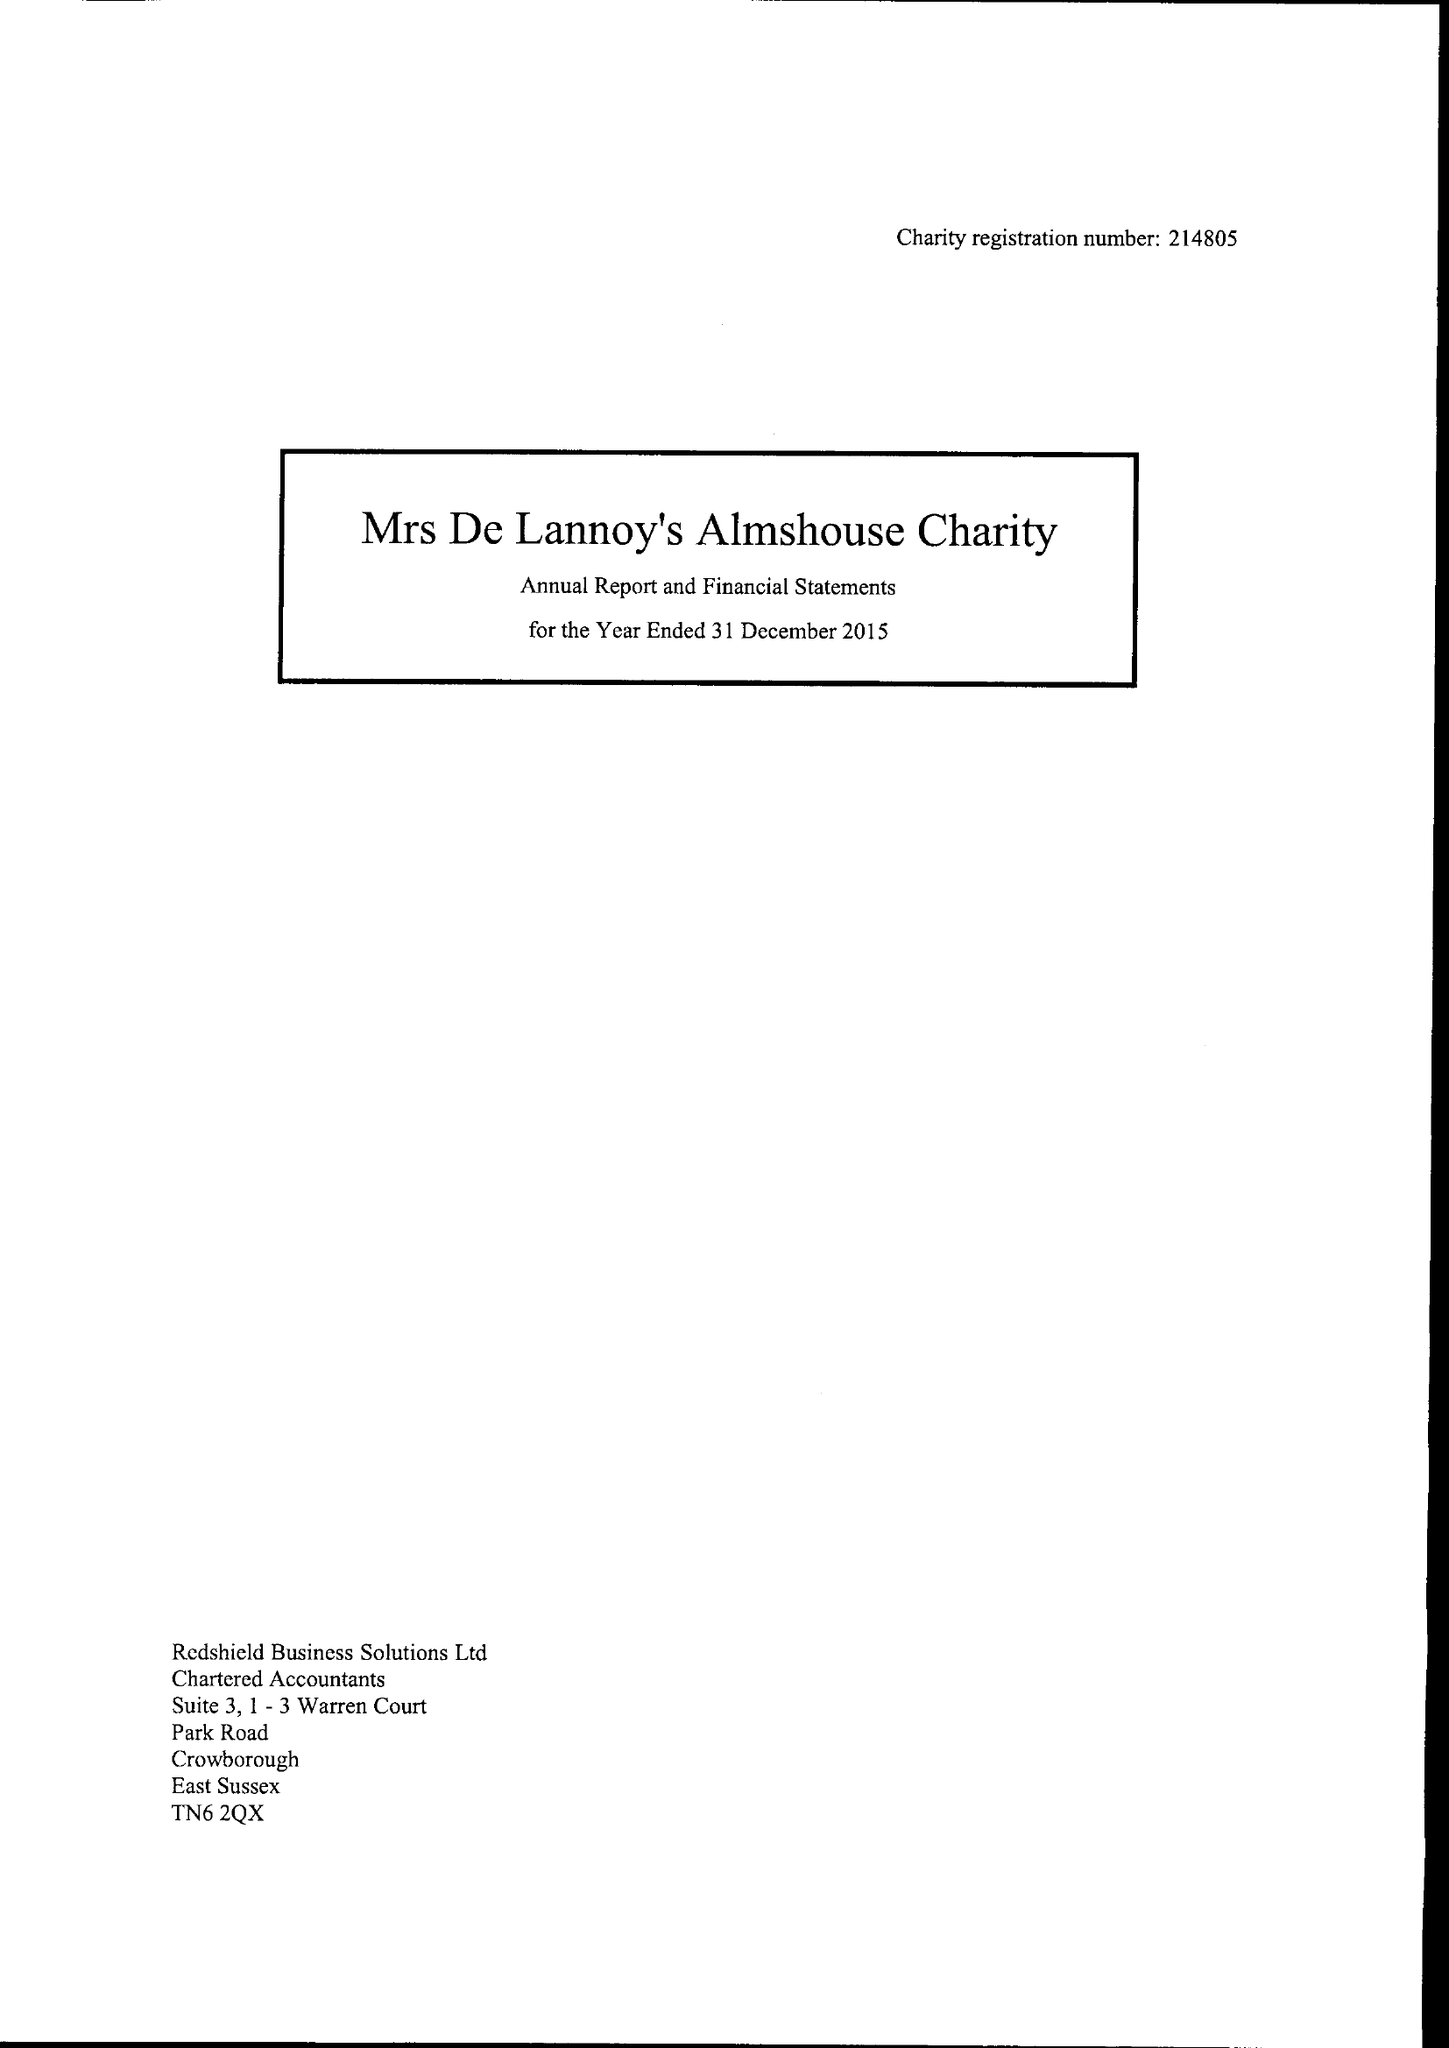What is the value for the income_annually_in_british_pounds?
Answer the question using a single word or phrase. 30546.00 